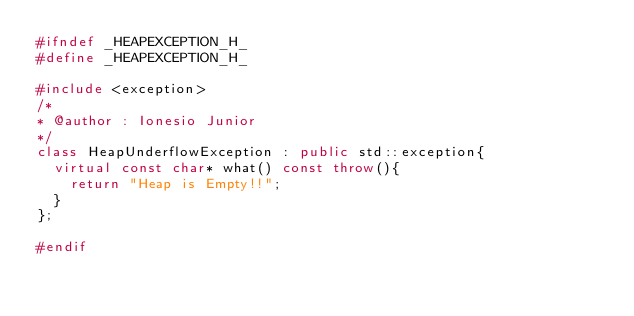<code> <loc_0><loc_0><loc_500><loc_500><_C++_>#ifndef _HEAPEXCEPTION_H_
#define _HEAPEXCEPTION_H_

#include <exception>
/*
* @author : Ionesio Junior
*/
class HeapUnderflowException : public std::exception{
	virtual const char* what() const throw(){
		return "Heap is Empty!!";
	}
};

#endif
</code> 